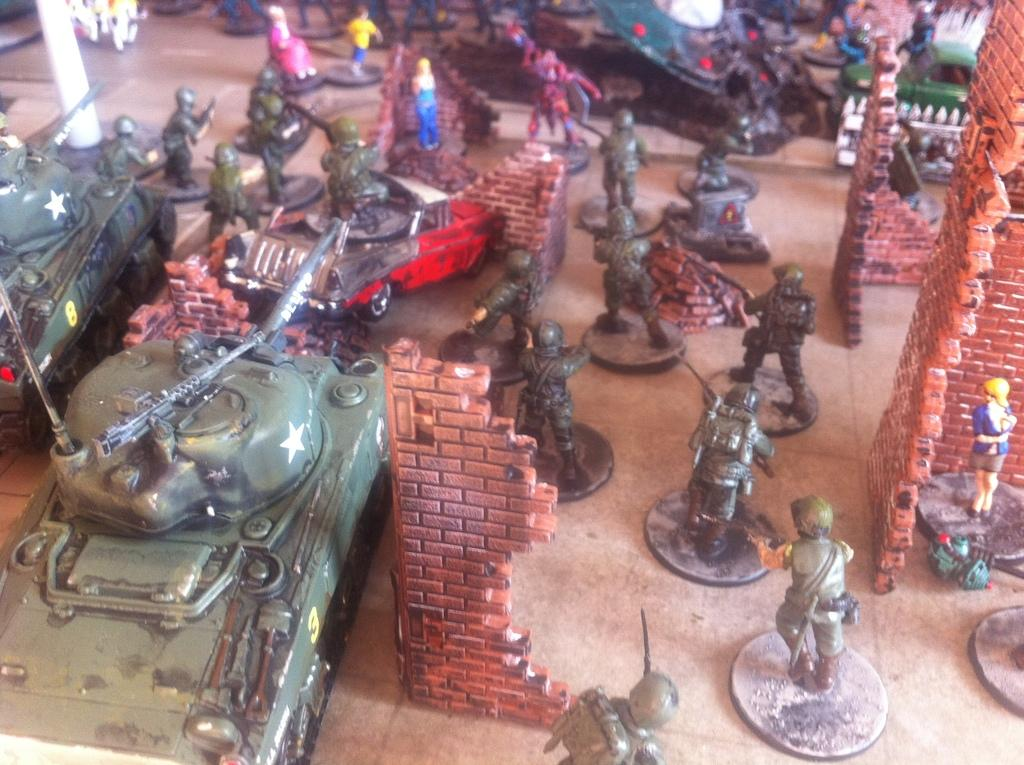What types of toys are present in the image? There are toys of persons and vehicles in the image. What kind of structures can be seen in the image? There are brick walls in the image. What is the platform in the image used for? The platform in the image is used to hold objects. What is the belief of the grandfather in the image? There is no grandfather or any indication of beliefs in the image. What type of cable is connected to the toys in the image? There are no cables connected to the toys in the image. 